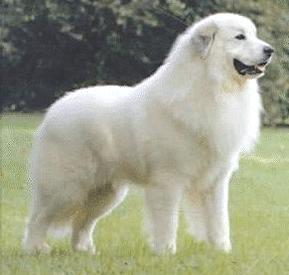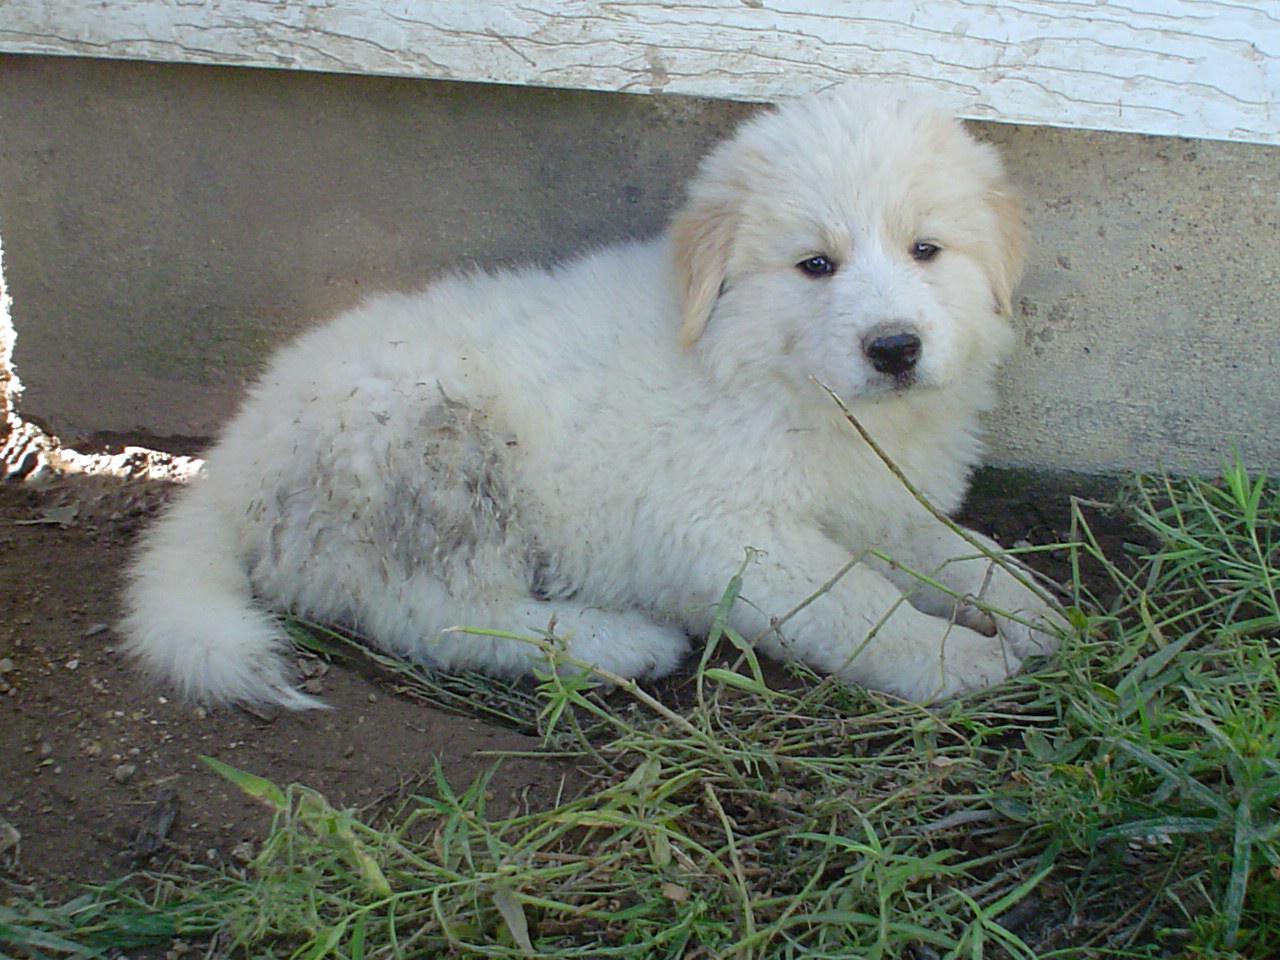The first image is the image on the left, the second image is the image on the right. For the images shown, is this caption "A white dog is standing and facing right" true? Answer yes or no. Yes. 